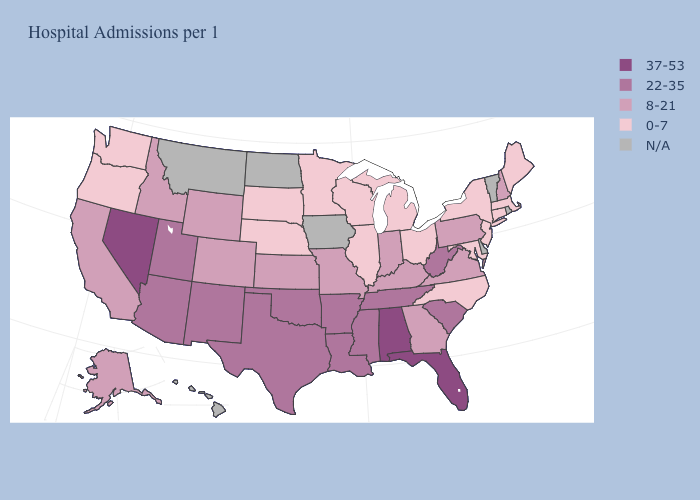Which states have the lowest value in the USA?
Give a very brief answer. Connecticut, Illinois, Maine, Maryland, Massachusetts, Michigan, Minnesota, Nebraska, New Jersey, New York, North Carolina, Ohio, Oregon, South Dakota, Washington, Wisconsin. What is the value of New Hampshire?
Write a very short answer. 8-21. Does Alabama have the highest value in the USA?
Answer briefly. Yes. Name the states that have a value in the range 0-7?
Keep it brief. Connecticut, Illinois, Maine, Maryland, Massachusetts, Michigan, Minnesota, Nebraska, New Jersey, New York, North Carolina, Ohio, Oregon, South Dakota, Washington, Wisconsin. What is the value of New Hampshire?
Quick response, please. 8-21. What is the value of Texas?
Short answer required. 22-35. Does the map have missing data?
Give a very brief answer. Yes. Name the states that have a value in the range 37-53?
Quick response, please. Alabama, Florida, Nevada. What is the lowest value in the Northeast?
Answer briefly. 0-7. Which states have the lowest value in the South?
Concise answer only. Maryland, North Carolina. What is the value of Wyoming?
Keep it brief. 8-21. What is the value of Pennsylvania?
Be succinct. 8-21. Among the states that border Wisconsin , which have the highest value?
Give a very brief answer. Illinois, Michigan, Minnesota. Is the legend a continuous bar?
Write a very short answer. No. 